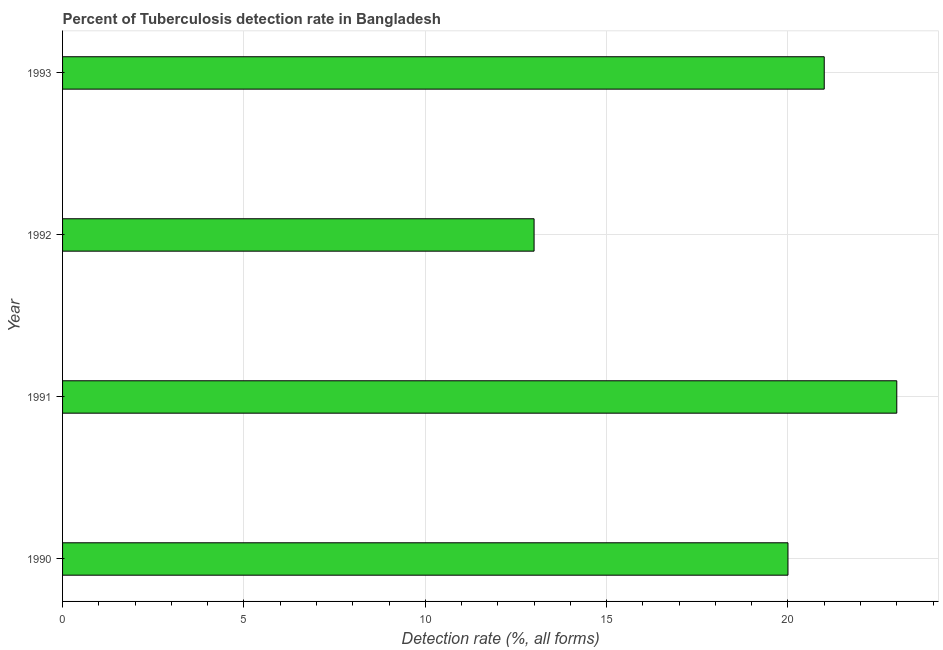Does the graph contain any zero values?
Make the answer very short. No. What is the title of the graph?
Give a very brief answer. Percent of Tuberculosis detection rate in Bangladesh. What is the label or title of the X-axis?
Make the answer very short. Detection rate (%, all forms). What is the label or title of the Y-axis?
Ensure brevity in your answer.  Year. What is the detection rate of tuberculosis in 1991?
Your answer should be very brief. 23. Across all years, what is the maximum detection rate of tuberculosis?
Offer a terse response. 23. In which year was the detection rate of tuberculosis maximum?
Your answer should be very brief. 1991. In which year was the detection rate of tuberculosis minimum?
Provide a short and direct response. 1992. What is the sum of the detection rate of tuberculosis?
Give a very brief answer. 77. What is the difference between the detection rate of tuberculosis in 1990 and 1993?
Make the answer very short. -1. What is the median detection rate of tuberculosis?
Make the answer very short. 20.5. What is the ratio of the detection rate of tuberculosis in 1991 to that in 1992?
Your response must be concise. 1.77. Is the difference between the detection rate of tuberculosis in 1990 and 1991 greater than the difference between any two years?
Your answer should be compact. No. What is the difference between the highest and the second highest detection rate of tuberculosis?
Provide a succinct answer. 2. In how many years, is the detection rate of tuberculosis greater than the average detection rate of tuberculosis taken over all years?
Your response must be concise. 3. How many bars are there?
Offer a terse response. 4. What is the difference between two consecutive major ticks on the X-axis?
Provide a succinct answer. 5. What is the Detection rate (%, all forms) in 1990?
Offer a very short reply. 20. What is the Detection rate (%, all forms) of 1992?
Give a very brief answer. 13. What is the Detection rate (%, all forms) of 1993?
Offer a terse response. 21. What is the difference between the Detection rate (%, all forms) in 1990 and 1993?
Provide a succinct answer. -1. What is the difference between the Detection rate (%, all forms) in 1991 and 1992?
Make the answer very short. 10. What is the difference between the Detection rate (%, all forms) in 1991 and 1993?
Provide a succinct answer. 2. What is the ratio of the Detection rate (%, all forms) in 1990 to that in 1991?
Your response must be concise. 0.87. What is the ratio of the Detection rate (%, all forms) in 1990 to that in 1992?
Make the answer very short. 1.54. What is the ratio of the Detection rate (%, all forms) in 1990 to that in 1993?
Give a very brief answer. 0.95. What is the ratio of the Detection rate (%, all forms) in 1991 to that in 1992?
Provide a short and direct response. 1.77. What is the ratio of the Detection rate (%, all forms) in 1991 to that in 1993?
Provide a succinct answer. 1.09. What is the ratio of the Detection rate (%, all forms) in 1992 to that in 1993?
Give a very brief answer. 0.62. 